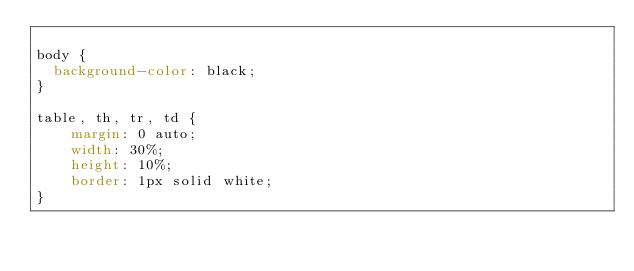<code> <loc_0><loc_0><loc_500><loc_500><_CSS_>
body {
  background-color: black;
}

table, th, tr, td {
    margin: 0 auto;
    width: 30%;
    height: 10%;
    border: 1px solid white;
}
</code> 